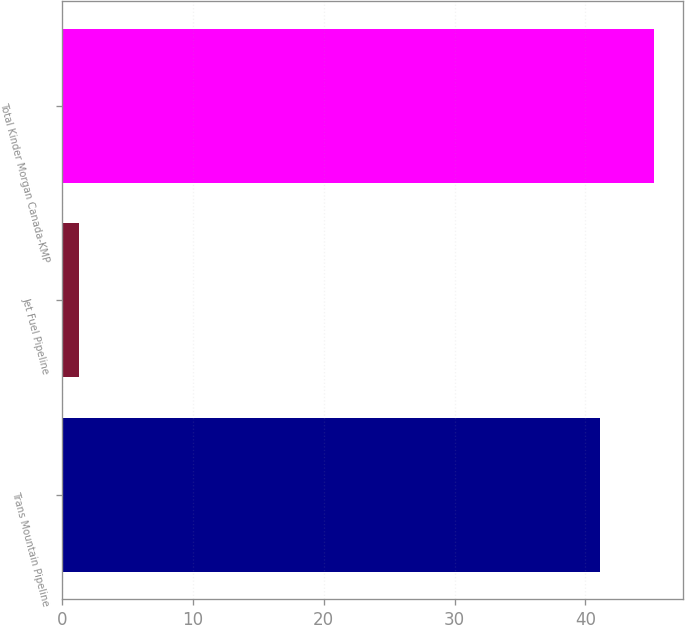<chart> <loc_0><loc_0><loc_500><loc_500><bar_chart><fcel>Trans Mountain Pipeline<fcel>Jet Fuel Pipeline<fcel>Total Kinder Morgan Canada-KMP<nl><fcel>41.1<fcel>1.3<fcel>45.21<nl></chart> 